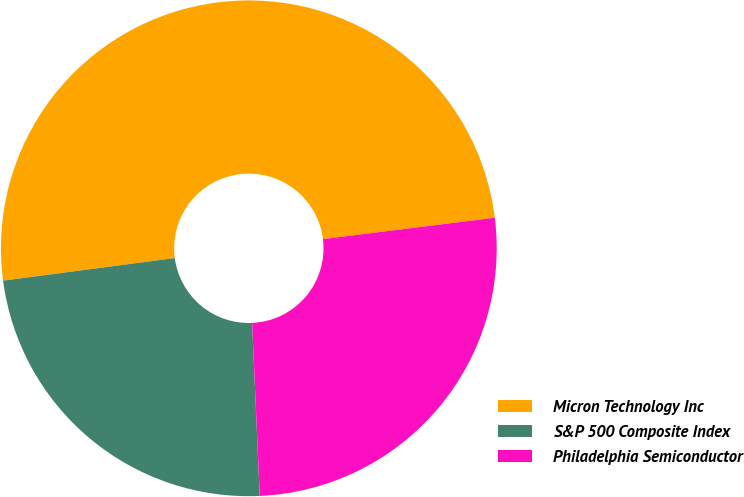Convert chart to OTSL. <chart><loc_0><loc_0><loc_500><loc_500><pie_chart><fcel>Micron Technology Inc<fcel>S&P 500 Composite Index<fcel>Philadelphia Semiconductor<nl><fcel>50.12%<fcel>23.62%<fcel>26.27%<nl></chart> 